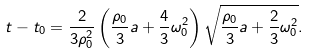Convert formula to latex. <formula><loc_0><loc_0><loc_500><loc_500>t - t _ { 0 } = \frac { 2 } { 3 \rho ^ { 2 } _ { 0 } } \left ( \frac { \rho _ { 0 } } { 3 } a + \frac { 4 } { 3 } \omega ^ { 2 } _ { 0 } \right ) \sqrt { \frac { \rho _ { 0 } } { 3 } a + \frac { 2 } { 3 } \omega ^ { 2 } _ { 0 } } .</formula> 